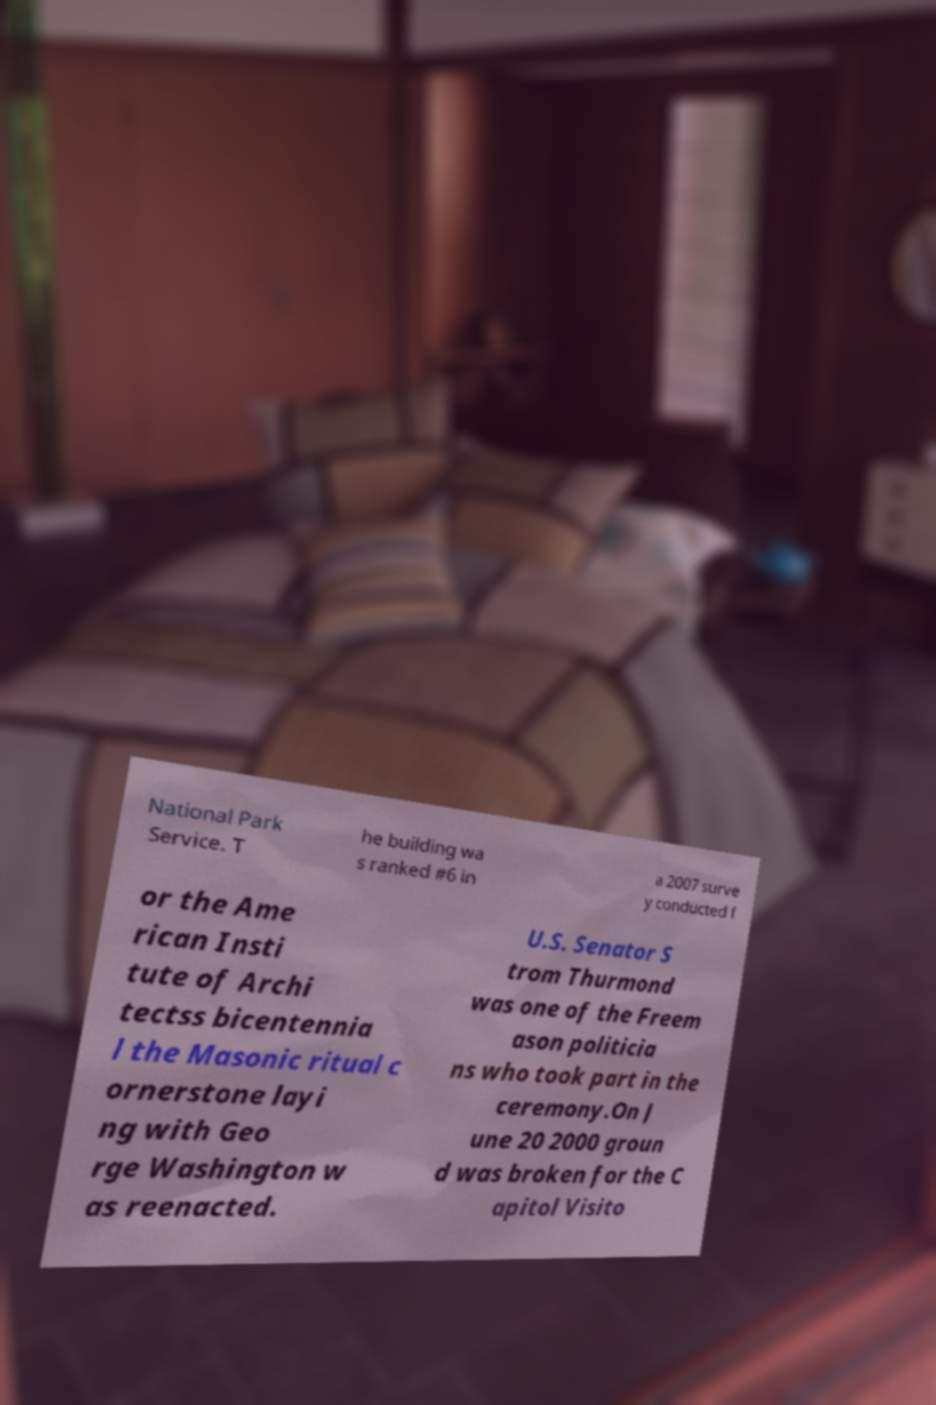I need the written content from this picture converted into text. Can you do that? National Park Service. T he building wa s ranked #6 in a 2007 surve y conducted f or the Ame rican Insti tute of Archi tectss bicentennia l the Masonic ritual c ornerstone layi ng with Geo rge Washington w as reenacted. U.S. Senator S trom Thurmond was one of the Freem ason politicia ns who took part in the ceremony.On J une 20 2000 groun d was broken for the C apitol Visito 